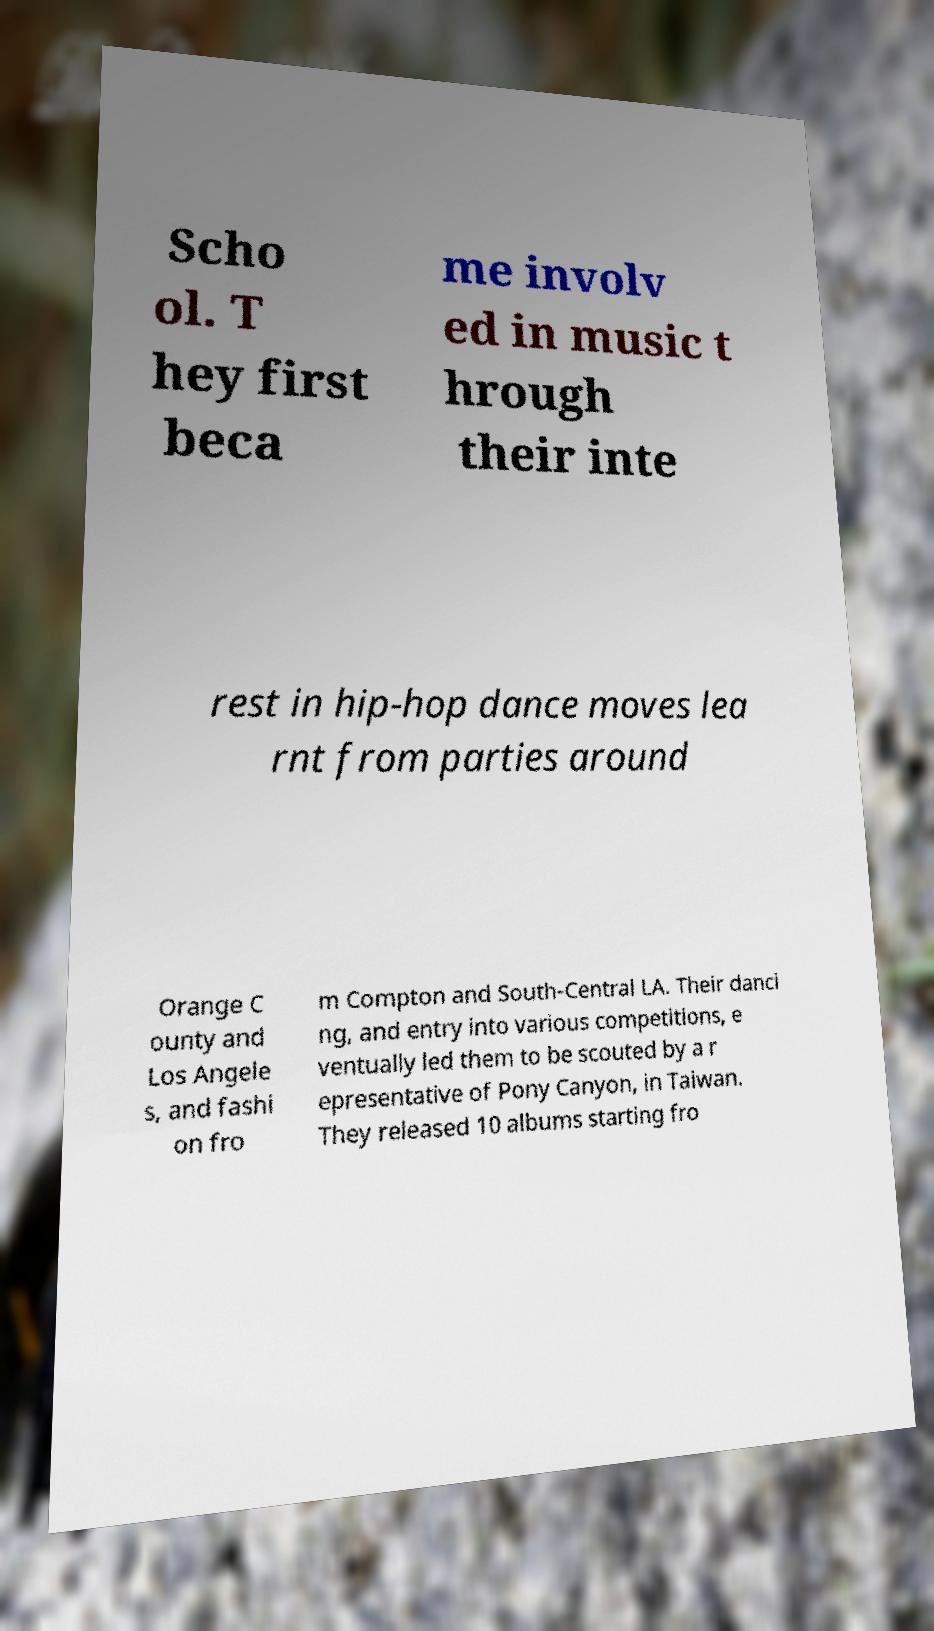Could you extract and type out the text from this image? Scho ol. T hey first beca me involv ed in music t hrough their inte rest in hip-hop dance moves lea rnt from parties around Orange C ounty and Los Angele s, and fashi on fro m Compton and South-Central LA. Their danci ng, and entry into various competitions, e ventually led them to be scouted by a r epresentative of Pony Canyon, in Taiwan. They released 10 albums starting fro 